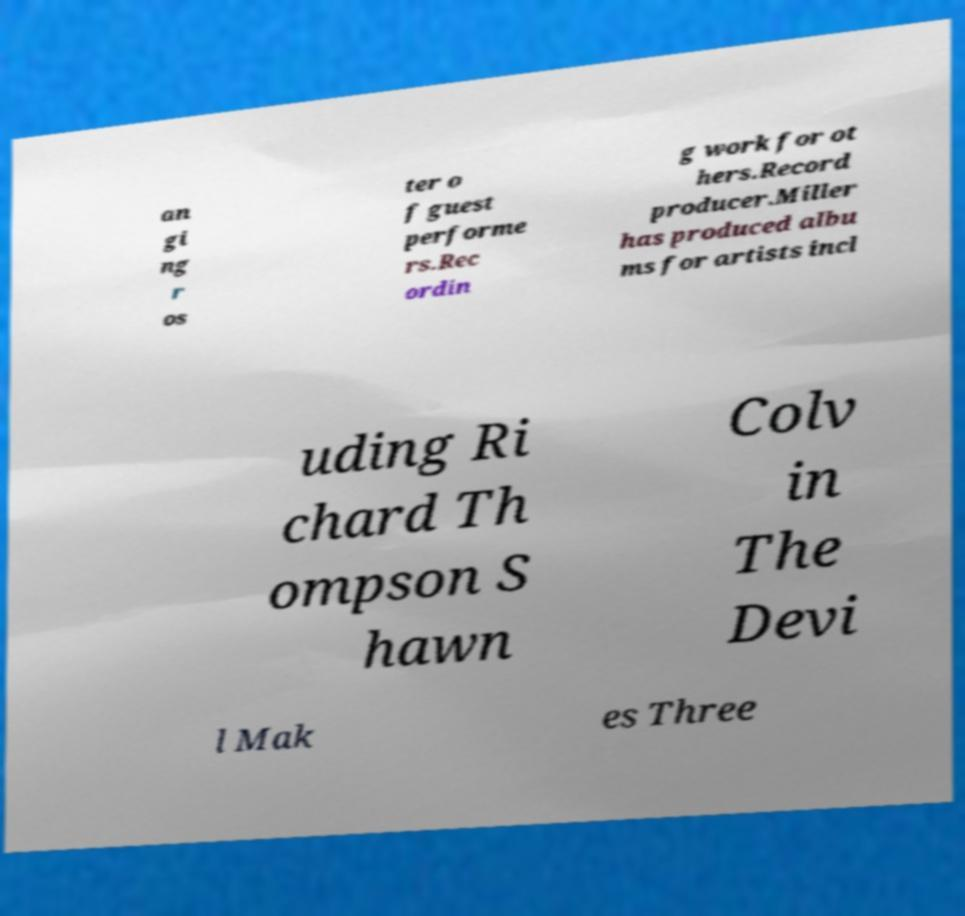For documentation purposes, I need the text within this image transcribed. Could you provide that? an gi ng r os ter o f guest performe rs.Rec ordin g work for ot hers.Record producer.Miller has produced albu ms for artists incl uding Ri chard Th ompson S hawn Colv in The Devi l Mak es Three 